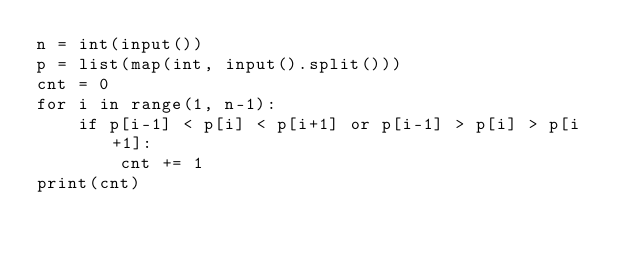<code> <loc_0><loc_0><loc_500><loc_500><_Python_>n = int(input())
p = list(map(int, input().split()))
cnt = 0
for i in range(1, n-1):
    if p[i-1] < p[i] < p[i+1] or p[i-1] > p[i] > p[i+1]:
        cnt += 1
print(cnt)</code> 